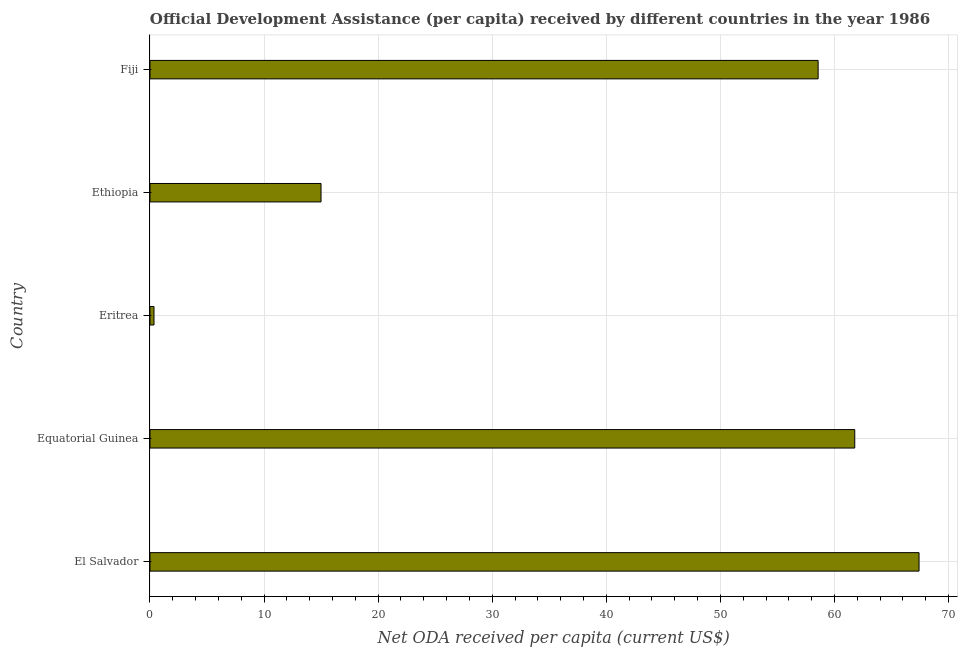What is the title of the graph?
Ensure brevity in your answer.  Official Development Assistance (per capita) received by different countries in the year 1986. What is the label or title of the X-axis?
Offer a terse response. Net ODA received per capita (current US$). What is the net oda received per capita in Eritrea?
Give a very brief answer. 0.35. Across all countries, what is the maximum net oda received per capita?
Ensure brevity in your answer.  67.41. Across all countries, what is the minimum net oda received per capita?
Your answer should be very brief. 0.35. In which country was the net oda received per capita maximum?
Give a very brief answer. El Salvador. In which country was the net oda received per capita minimum?
Your response must be concise. Eritrea. What is the sum of the net oda received per capita?
Offer a terse response. 203.09. What is the difference between the net oda received per capita in El Salvador and Eritrea?
Make the answer very short. 67.06. What is the average net oda received per capita per country?
Offer a terse response. 40.62. What is the median net oda received per capita?
Your response must be concise. 58.56. What is the ratio of the net oda received per capita in Equatorial Guinea to that in Fiji?
Provide a succinct answer. 1.05. Is the net oda received per capita in Ethiopia less than that in Fiji?
Provide a succinct answer. Yes. What is the difference between the highest and the second highest net oda received per capita?
Your response must be concise. 5.64. What is the difference between the highest and the lowest net oda received per capita?
Ensure brevity in your answer.  67.06. How many bars are there?
Your answer should be compact. 5. Are all the bars in the graph horizontal?
Ensure brevity in your answer.  Yes. How many countries are there in the graph?
Your answer should be compact. 5. What is the difference between two consecutive major ticks on the X-axis?
Keep it short and to the point. 10. Are the values on the major ticks of X-axis written in scientific E-notation?
Your answer should be very brief. No. What is the Net ODA received per capita (current US$) of El Salvador?
Your answer should be very brief. 67.41. What is the Net ODA received per capita (current US$) of Equatorial Guinea?
Provide a succinct answer. 61.77. What is the Net ODA received per capita (current US$) in Eritrea?
Your answer should be compact. 0.35. What is the Net ODA received per capita (current US$) of Ethiopia?
Give a very brief answer. 14.99. What is the Net ODA received per capita (current US$) of Fiji?
Offer a very short reply. 58.56. What is the difference between the Net ODA received per capita (current US$) in El Salvador and Equatorial Guinea?
Offer a terse response. 5.64. What is the difference between the Net ODA received per capita (current US$) in El Salvador and Eritrea?
Offer a very short reply. 67.06. What is the difference between the Net ODA received per capita (current US$) in El Salvador and Ethiopia?
Offer a terse response. 52.42. What is the difference between the Net ODA received per capita (current US$) in El Salvador and Fiji?
Make the answer very short. 8.85. What is the difference between the Net ODA received per capita (current US$) in Equatorial Guinea and Eritrea?
Provide a succinct answer. 61.42. What is the difference between the Net ODA received per capita (current US$) in Equatorial Guinea and Ethiopia?
Provide a succinct answer. 46.78. What is the difference between the Net ODA received per capita (current US$) in Equatorial Guinea and Fiji?
Your answer should be very brief. 3.21. What is the difference between the Net ODA received per capita (current US$) in Eritrea and Ethiopia?
Give a very brief answer. -14.64. What is the difference between the Net ODA received per capita (current US$) in Eritrea and Fiji?
Offer a very short reply. -58.21. What is the difference between the Net ODA received per capita (current US$) in Ethiopia and Fiji?
Make the answer very short. -43.57. What is the ratio of the Net ODA received per capita (current US$) in El Salvador to that in Equatorial Guinea?
Keep it short and to the point. 1.09. What is the ratio of the Net ODA received per capita (current US$) in El Salvador to that in Eritrea?
Provide a succinct answer. 191.65. What is the ratio of the Net ODA received per capita (current US$) in El Salvador to that in Ethiopia?
Your answer should be compact. 4.5. What is the ratio of the Net ODA received per capita (current US$) in El Salvador to that in Fiji?
Give a very brief answer. 1.15. What is the ratio of the Net ODA received per capita (current US$) in Equatorial Guinea to that in Eritrea?
Give a very brief answer. 175.63. What is the ratio of the Net ODA received per capita (current US$) in Equatorial Guinea to that in Ethiopia?
Offer a terse response. 4.12. What is the ratio of the Net ODA received per capita (current US$) in Equatorial Guinea to that in Fiji?
Your response must be concise. 1.05. What is the ratio of the Net ODA received per capita (current US$) in Eritrea to that in Ethiopia?
Make the answer very short. 0.02. What is the ratio of the Net ODA received per capita (current US$) in Eritrea to that in Fiji?
Provide a succinct answer. 0.01. What is the ratio of the Net ODA received per capita (current US$) in Ethiopia to that in Fiji?
Your answer should be very brief. 0.26. 